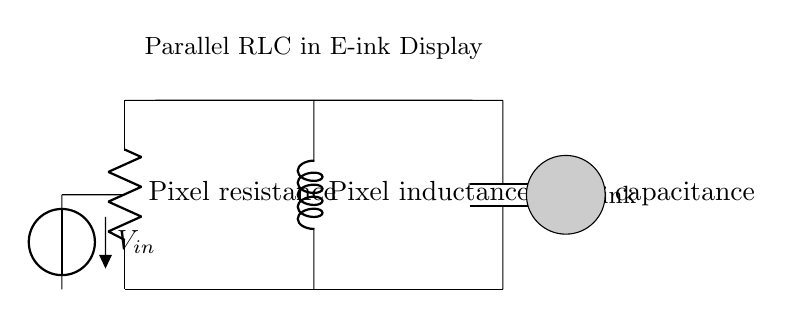What are the components in this circuit? The circuit consists of a resistor, inductor, and capacitor arranged in parallel. These elements are labeled as R for resistance, L for inductance, and C for capacitance, indicating their roles in the circuit.
Answer: resistor, inductor, capacitor What is the labeled voltage source in this circuit? The voltage source is labeled as V with an input voltage notation, indicating it provides the potential difference necessary for circuit operation, typically from a battery or power supply.
Answer: V_in What is the function of the resistor in this circuit? The resistor, labeled as R, serves as the pixel resistance in the e-ink display, limiting the current flow and thus controlling how much power is used by each pixel, affecting brightness and energy efficiency.
Answer: Pixel resistance How are the components connected in this circuit? The resistor, inductor, and capacitor are connected in parallel, meaning they share the same two terminals, allowing current to divide among them while maintaining the same voltage across each component.
Answer: Parallel connection What type of circuit is shown? This is a parallel RLC circuit, which combines a resistor, inductor, and capacitor to form a resonant circuit that can filter frequencies and is used effectively in e-ink displays for their response times.
Answer: Parallel RLC What is the primary application of this RLC circuit in the e-ink display? This circuit is utilized for comfortable long-form reading by managing the response time and refresh rate of the pixels, ensuring that the display provides a stable and flicker-free reading experience.
Answer: Long-form reading What is the significance of using inductance in this circuit? Inductance in this circuit helps with smoothing out variations in current, providing a stable response in conjunction with capacitance, which is important for maintaining image stability and quality in e-ink displays.
Answer: Smoothing current variations 